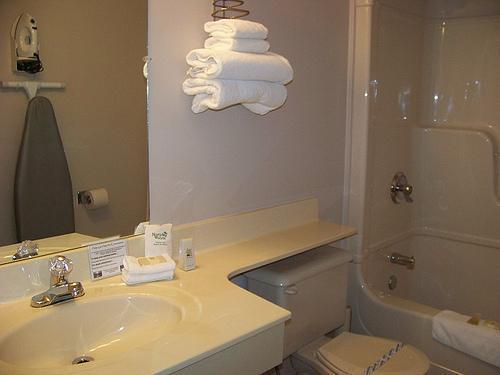How many towels are on the rack?
Give a very brief answer. 4. How many rolls of toilet paper do you see?
Give a very brief answer. 0. 